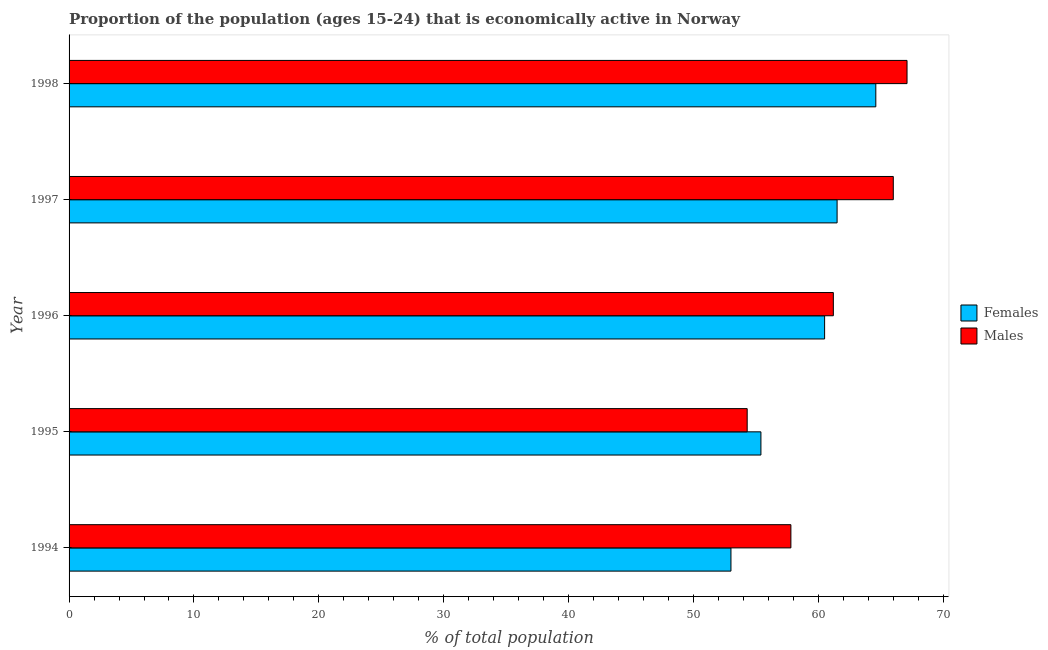How many groups of bars are there?
Offer a very short reply. 5. Are the number of bars on each tick of the Y-axis equal?
Give a very brief answer. Yes. What is the label of the 5th group of bars from the top?
Your answer should be compact. 1994. What is the percentage of economically active female population in 1996?
Your response must be concise. 60.5. Across all years, what is the maximum percentage of economically active female population?
Your answer should be very brief. 64.6. Across all years, what is the minimum percentage of economically active female population?
Your answer should be very brief. 53. In which year was the percentage of economically active female population minimum?
Your response must be concise. 1994. What is the total percentage of economically active female population in the graph?
Your answer should be compact. 295. What is the difference between the percentage of economically active female population in 1997 and the percentage of economically active male population in 1995?
Your answer should be very brief. 7.2. In how many years, is the percentage of economically active male population greater than 4 %?
Ensure brevity in your answer.  5. What is the ratio of the percentage of economically active female population in 1995 to that in 1998?
Make the answer very short. 0.86. Is the percentage of economically active male population in 1994 less than that in 1997?
Give a very brief answer. Yes. What is the difference between the highest and the second highest percentage of economically active female population?
Your response must be concise. 3.1. What is the difference between the highest and the lowest percentage of economically active female population?
Offer a very short reply. 11.6. In how many years, is the percentage of economically active female population greater than the average percentage of economically active female population taken over all years?
Keep it short and to the point. 3. Is the sum of the percentage of economically active male population in 1995 and 1996 greater than the maximum percentage of economically active female population across all years?
Offer a terse response. Yes. What does the 1st bar from the top in 1998 represents?
Give a very brief answer. Males. What does the 1st bar from the bottom in 1997 represents?
Give a very brief answer. Females. How many bars are there?
Your answer should be very brief. 10. Are all the bars in the graph horizontal?
Your answer should be compact. Yes. Are the values on the major ticks of X-axis written in scientific E-notation?
Make the answer very short. No. Does the graph contain any zero values?
Your answer should be very brief. No. Does the graph contain grids?
Provide a short and direct response. No. How many legend labels are there?
Your answer should be compact. 2. What is the title of the graph?
Offer a very short reply. Proportion of the population (ages 15-24) that is economically active in Norway. What is the label or title of the X-axis?
Give a very brief answer. % of total population. What is the % of total population in Males in 1994?
Give a very brief answer. 57.8. What is the % of total population of Females in 1995?
Offer a very short reply. 55.4. What is the % of total population in Males in 1995?
Provide a short and direct response. 54.3. What is the % of total population in Females in 1996?
Offer a very short reply. 60.5. What is the % of total population of Males in 1996?
Ensure brevity in your answer.  61.2. What is the % of total population of Females in 1997?
Your answer should be compact. 61.5. What is the % of total population of Males in 1997?
Your response must be concise. 66. What is the % of total population of Females in 1998?
Keep it short and to the point. 64.6. What is the % of total population of Males in 1998?
Your response must be concise. 67.1. Across all years, what is the maximum % of total population of Females?
Your response must be concise. 64.6. Across all years, what is the maximum % of total population of Males?
Offer a terse response. 67.1. Across all years, what is the minimum % of total population of Males?
Your response must be concise. 54.3. What is the total % of total population in Females in the graph?
Keep it short and to the point. 295. What is the total % of total population in Males in the graph?
Provide a short and direct response. 306.4. What is the difference between the % of total population of Males in 1994 and that in 1996?
Offer a very short reply. -3.4. What is the difference between the % of total population in Females in 1994 and that in 1997?
Provide a succinct answer. -8.5. What is the difference between the % of total population of Males in 1994 and that in 1997?
Offer a terse response. -8.2. What is the difference between the % of total population in Females in 1994 and that in 1998?
Offer a very short reply. -11.6. What is the difference between the % of total population in Males in 1994 and that in 1998?
Ensure brevity in your answer.  -9.3. What is the difference between the % of total population in Females in 1995 and that in 1996?
Your answer should be compact. -5.1. What is the difference between the % of total population of Males in 1995 and that in 1997?
Your answer should be compact. -11.7. What is the difference between the % of total population of Females in 1995 and that in 1998?
Make the answer very short. -9.2. What is the difference between the % of total population in Males in 1996 and that in 1997?
Make the answer very short. -4.8. What is the difference between the % of total population of Females in 1996 and that in 1998?
Your answer should be very brief. -4.1. What is the difference between the % of total population of Females in 1997 and that in 1998?
Your response must be concise. -3.1. What is the difference between the % of total population of Males in 1997 and that in 1998?
Offer a terse response. -1.1. What is the difference between the % of total population in Females in 1994 and the % of total population in Males in 1995?
Your response must be concise. -1.3. What is the difference between the % of total population of Females in 1994 and the % of total population of Males in 1998?
Provide a succinct answer. -14.1. What is the difference between the % of total population of Females in 1995 and the % of total population of Males in 1998?
Provide a succinct answer. -11.7. What is the difference between the % of total population in Females in 1997 and the % of total population in Males in 1998?
Provide a succinct answer. -5.6. What is the average % of total population of Males per year?
Offer a very short reply. 61.28. In the year 1995, what is the difference between the % of total population in Females and % of total population in Males?
Provide a succinct answer. 1.1. In the year 1996, what is the difference between the % of total population in Females and % of total population in Males?
Keep it short and to the point. -0.7. In the year 1998, what is the difference between the % of total population in Females and % of total population in Males?
Your answer should be very brief. -2.5. What is the ratio of the % of total population of Females in 1994 to that in 1995?
Offer a very short reply. 0.96. What is the ratio of the % of total population of Males in 1994 to that in 1995?
Make the answer very short. 1.06. What is the ratio of the % of total population of Females in 1994 to that in 1996?
Your response must be concise. 0.88. What is the ratio of the % of total population of Males in 1994 to that in 1996?
Your answer should be very brief. 0.94. What is the ratio of the % of total population in Females in 1994 to that in 1997?
Provide a short and direct response. 0.86. What is the ratio of the % of total population of Males in 1994 to that in 1997?
Provide a short and direct response. 0.88. What is the ratio of the % of total population in Females in 1994 to that in 1998?
Give a very brief answer. 0.82. What is the ratio of the % of total population in Males in 1994 to that in 1998?
Your answer should be very brief. 0.86. What is the ratio of the % of total population in Females in 1995 to that in 1996?
Provide a succinct answer. 0.92. What is the ratio of the % of total population in Males in 1995 to that in 1996?
Offer a very short reply. 0.89. What is the ratio of the % of total population in Females in 1995 to that in 1997?
Give a very brief answer. 0.9. What is the ratio of the % of total population in Males in 1995 to that in 1997?
Keep it short and to the point. 0.82. What is the ratio of the % of total population of Females in 1995 to that in 1998?
Provide a succinct answer. 0.86. What is the ratio of the % of total population of Males in 1995 to that in 1998?
Provide a short and direct response. 0.81. What is the ratio of the % of total population in Females in 1996 to that in 1997?
Offer a very short reply. 0.98. What is the ratio of the % of total population in Males in 1996 to that in 1997?
Offer a terse response. 0.93. What is the ratio of the % of total population in Females in 1996 to that in 1998?
Your answer should be compact. 0.94. What is the ratio of the % of total population in Males in 1996 to that in 1998?
Provide a succinct answer. 0.91. What is the ratio of the % of total population of Females in 1997 to that in 1998?
Provide a succinct answer. 0.95. What is the ratio of the % of total population in Males in 1997 to that in 1998?
Your response must be concise. 0.98. What is the difference between the highest and the lowest % of total population of Males?
Ensure brevity in your answer.  12.8. 